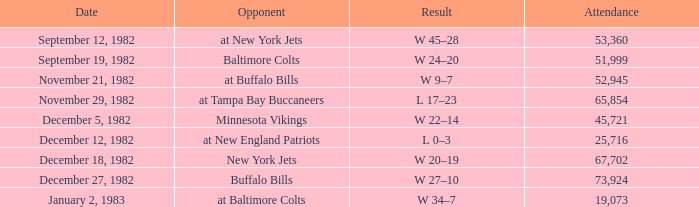What week was the game on September 12, 1982 with an attendance greater than 51,999? 1.0. 